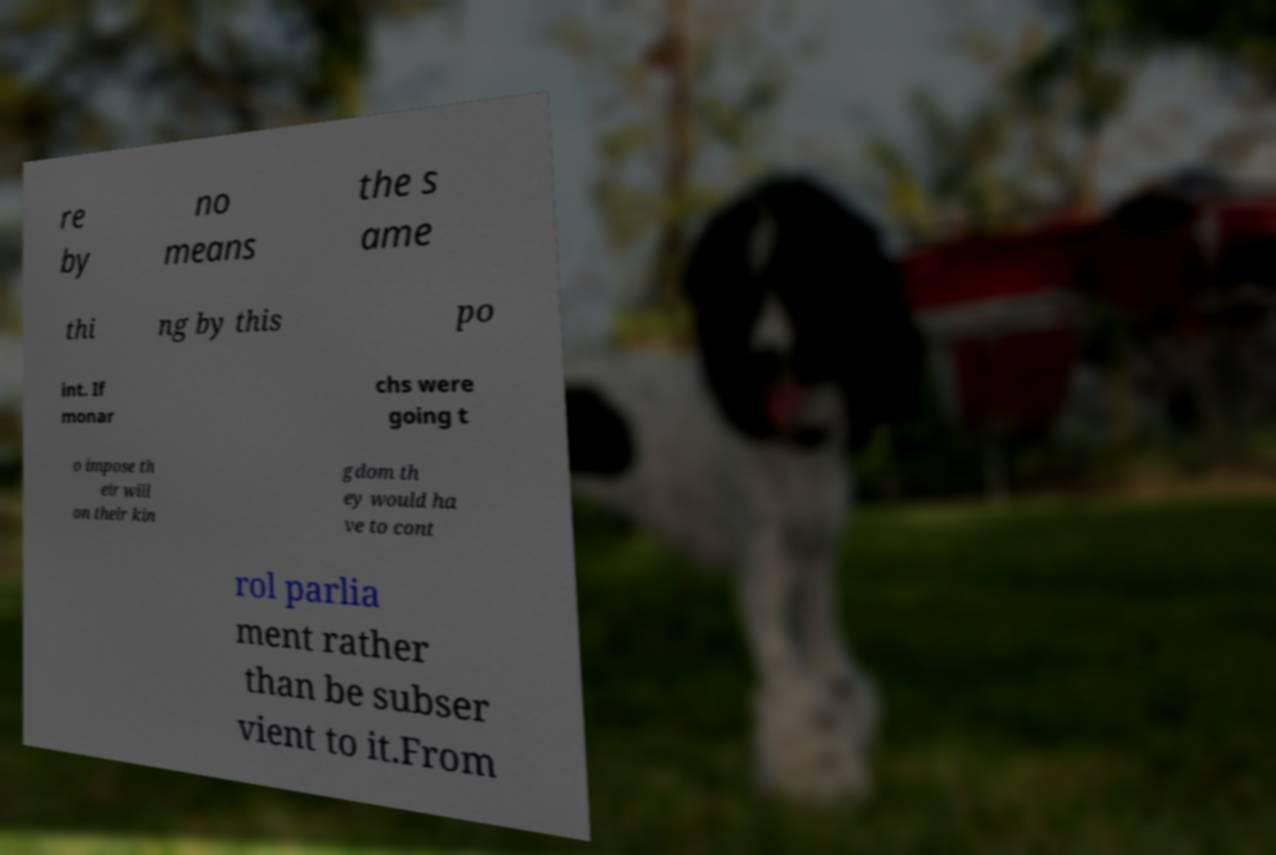Could you assist in decoding the text presented in this image and type it out clearly? re by no means the s ame thi ng by this po int. If monar chs were going t o impose th eir will on their kin gdom th ey would ha ve to cont rol parlia ment rather than be subser vient to it.From 